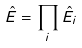Convert formula to latex. <formula><loc_0><loc_0><loc_500><loc_500>\hat { E } = \prod _ { i } \hat { E } _ { i }</formula> 